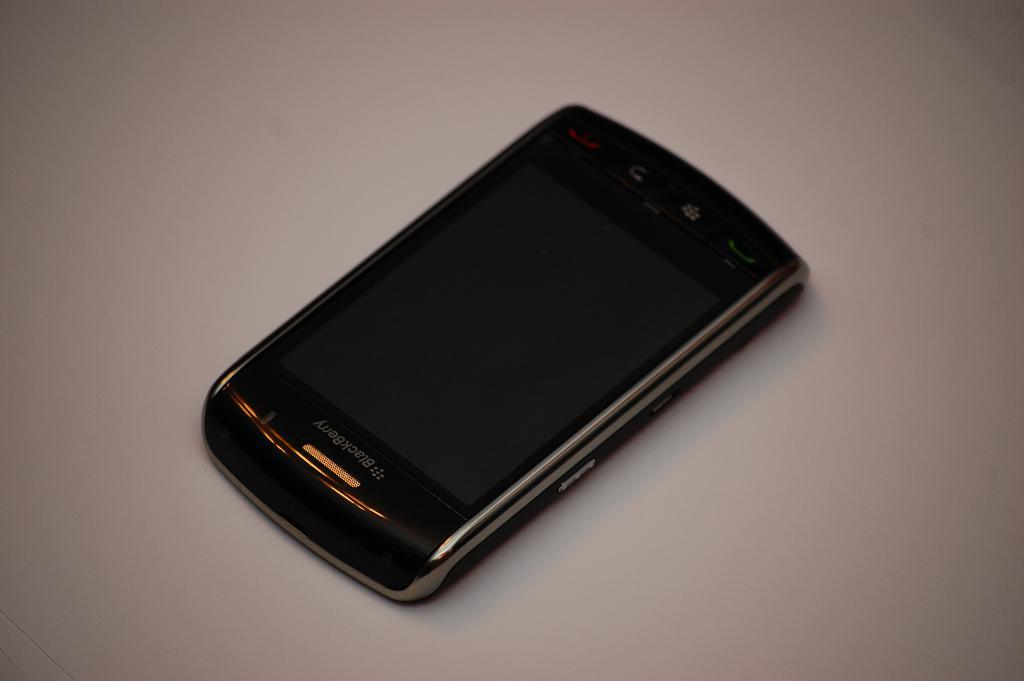<image>
Summarize the visual content of the image. A black BlackBerry sits on a white table. 